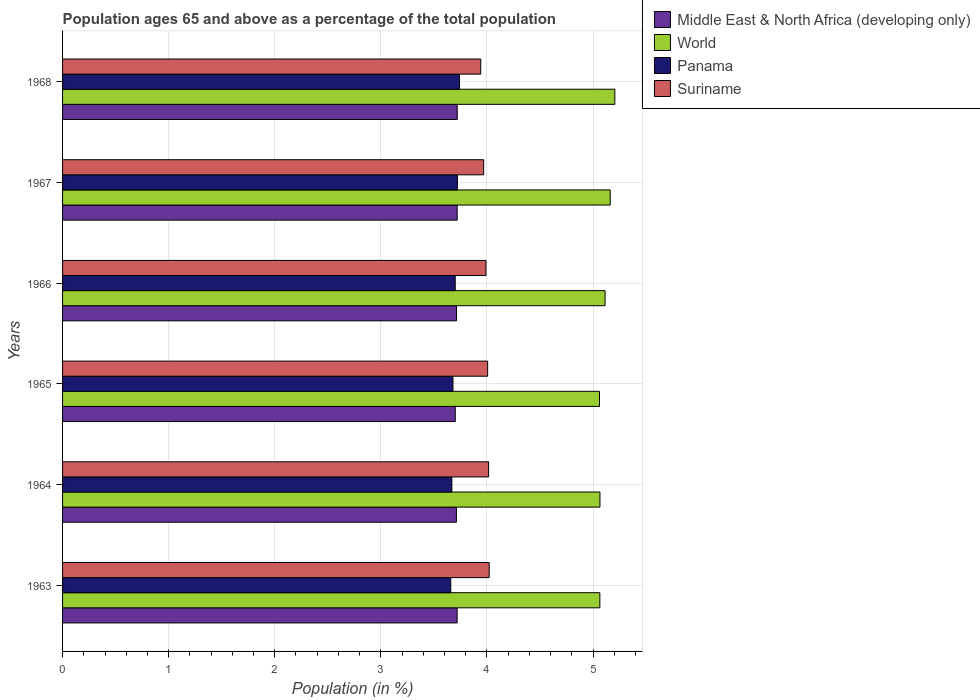How many bars are there on the 4th tick from the bottom?
Give a very brief answer. 4. What is the label of the 1st group of bars from the top?
Offer a very short reply. 1968. What is the percentage of the population ages 65 and above in Middle East & North Africa (developing only) in 1963?
Your response must be concise. 3.72. Across all years, what is the maximum percentage of the population ages 65 and above in Suriname?
Ensure brevity in your answer.  4.02. Across all years, what is the minimum percentage of the population ages 65 and above in Middle East & North Africa (developing only)?
Give a very brief answer. 3.7. In which year was the percentage of the population ages 65 and above in Panama maximum?
Keep it short and to the point. 1968. In which year was the percentage of the population ages 65 and above in Middle East & North Africa (developing only) minimum?
Offer a terse response. 1965. What is the total percentage of the population ages 65 and above in Middle East & North Africa (developing only) in the graph?
Keep it short and to the point. 22.28. What is the difference between the percentage of the population ages 65 and above in Suriname in 1966 and that in 1968?
Provide a short and direct response. 0.05. What is the difference between the percentage of the population ages 65 and above in World in 1966 and the percentage of the population ages 65 and above in Panama in 1967?
Your response must be concise. 1.39. What is the average percentage of the population ages 65 and above in Panama per year?
Offer a very short reply. 3.7. In the year 1967, what is the difference between the percentage of the population ages 65 and above in Suriname and percentage of the population ages 65 and above in Panama?
Your answer should be very brief. 0.25. What is the ratio of the percentage of the population ages 65 and above in Middle East & North Africa (developing only) in 1963 to that in 1964?
Keep it short and to the point. 1. Is the difference between the percentage of the population ages 65 and above in Suriname in 1964 and 1966 greater than the difference between the percentage of the population ages 65 and above in Panama in 1964 and 1966?
Ensure brevity in your answer.  Yes. What is the difference between the highest and the second highest percentage of the population ages 65 and above in Middle East & North Africa (developing only)?
Offer a terse response. 0. What is the difference between the highest and the lowest percentage of the population ages 65 and above in World?
Keep it short and to the point. 0.14. In how many years, is the percentage of the population ages 65 and above in World greater than the average percentage of the population ages 65 and above in World taken over all years?
Offer a very short reply. 3. Is the sum of the percentage of the population ages 65 and above in Panama in 1966 and 1967 greater than the maximum percentage of the population ages 65 and above in Suriname across all years?
Offer a terse response. Yes. Is it the case that in every year, the sum of the percentage of the population ages 65 and above in Middle East & North Africa (developing only) and percentage of the population ages 65 and above in World is greater than the sum of percentage of the population ages 65 and above in Panama and percentage of the population ages 65 and above in Suriname?
Keep it short and to the point. Yes. What does the 3rd bar from the bottom in 1964 represents?
Provide a short and direct response. Panama. How many years are there in the graph?
Keep it short and to the point. 6. Are the values on the major ticks of X-axis written in scientific E-notation?
Your answer should be compact. No. Where does the legend appear in the graph?
Offer a terse response. Top right. What is the title of the graph?
Your response must be concise. Population ages 65 and above as a percentage of the total population. Does "Caribbean small states" appear as one of the legend labels in the graph?
Your answer should be compact. No. What is the label or title of the Y-axis?
Offer a terse response. Years. What is the Population (in %) of Middle East & North Africa (developing only) in 1963?
Ensure brevity in your answer.  3.72. What is the Population (in %) in World in 1963?
Offer a very short reply. 5.06. What is the Population (in %) of Panama in 1963?
Make the answer very short. 3.66. What is the Population (in %) of Suriname in 1963?
Make the answer very short. 4.02. What is the Population (in %) of Middle East & North Africa (developing only) in 1964?
Offer a very short reply. 3.71. What is the Population (in %) in World in 1964?
Provide a short and direct response. 5.07. What is the Population (in %) of Panama in 1964?
Offer a terse response. 3.67. What is the Population (in %) of Suriname in 1964?
Make the answer very short. 4.02. What is the Population (in %) of Middle East & North Africa (developing only) in 1965?
Provide a short and direct response. 3.7. What is the Population (in %) in World in 1965?
Provide a succinct answer. 5.06. What is the Population (in %) of Panama in 1965?
Ensure brevity in your answer.  3.68. What is the Population (in %) in Suriname in 1965?
Offer a terse response. 4.01. What is the Population (in %) in Middle East & North Africa (developing only) in 1966?
Provide a succinct answer. 3.71. What is the Population (in %) in World in 1966?
Provide a short and direct response. 5.11. What is the Population (in %) in Panama in 1966?
Your answer should be compact. 3.7. What is the Population (in %) in Suriname in 1966?
Your answer should be compact. 3.99. What is the Population (in %) in Middle East & North Africa (developing only) in 1967?
Your response must be concise. 3.72. What is the Population (in %) of World in 1967?
Give a very brief answer. 5.16. What is the Population (in %) of Panama in 1967?
Give a very brief answer. 3.72. What is the Population (in %) of Suriname in 1967?
Your answer should be compact. 3.97. What is the Population (in %) in Middle East & North Africa (developing only) in 1968?
Provide a short and direct response. 3.72. What is the Population (in %) in World in 1968?
Your answer should be compact. 5.21. What is the Population (in %) of Panama in 1968?
Provide a succinct answer. 3.74. What is the Population (in %) in Suriname in 1968?
Your answer should be very brief. 3.94. Across all years, what is the maximum Population (in %) in Middle East & North Africa (developing only)?
Provide a short and direct response. 3.72. Across all years, what is the maximum Population (in %) of World?
Your answer should be compact. 5.21. Across all years, what is the maximum Population (in %) in Panama?
Your response must be concise. 3.74. Across all years, what is the maximum Population (in %) in Suriname?
Offer a terse response. 4.02. Across all years, what is the minimum Population (in %) in Middle East & North Africa (developing only)?
Your response must be concise. 3.7. Across all years, what is the minimum Population (in %) in World?
Provide a succinct answer. 5.06. Across all years, what is the minimum Population (in %) of Panama?
Make the answer very short. 3.66. Across all years, what is the minimum Population (in %) of Suriname?
Ensure brevity in your answer.  3.94. What is the total Population (in %) in Middle East & North Africa (developing only) in the graph?
Your answer should be very brief. 22.28. What is the total Population (in %) of World in the graph?
Provide a succinct answer. 30.67. What is the total Population (in %) in Panama in the graph?
Your answer should be very brief. 22.17. What is the total Population (in %) of Suriname in the graph?
Provide a short and direct response. 23.94. What is the difference between the Population (in %) in Middle East & North Africa (developing only) in 1963 and that in 1964?
Give a very brief answer. 0.01. What is the difference between the Population (in %) of World in 1963 and that in 1964?
Keep it short and to the point. -0. What is the difference between the Population (in %) in Panama in 1963 and that in 1964?
Ensure brevity in your answer.  -0.01. What is the difference between the Population (in %) of Suriname in 1963 and that in 1964?
Offer a terse response. 0.01. What is the difference between the Population (in %) in Middle East & North Africa (developing only) in 1963 and that in 1965?
Your answer should be very brief. 0.02. What is the difference between the Population (in %) of World in 1963 and that in 1965?
Provide a succinct answer. 0. What is the difference between the Population (in %) in Panama in 1963 and that in 1965?
Your answer should be very brief. -0.02. What is the difference between the Population (in %) in Suriname in 1963 and that in 1965?
Provide a short and direct response. 0.01. What is the difference between the Population (in %) of Middle East & North Africa (developing only) in 1963 and that in 1966?
Make the answer very short. 0.01. What is the difference between the Population (in %) of World in 1963 and that in 1966?
Your response must be concise. -0.05. What is the difference between the Population (in %) of Panama in 1963 and that in 1966?
Ensure brevity in your answer.  -0.04. What is the difference between the Population (in %) in Suriname in 1963 and that in 1966?
Make the answer very short. 0.03. What is the difference between the Population (in %) of Middle East & North Africa (developing only) in 1963 and that in 1967?
Offer a terse response. -0. What is the difference between the Population (in %) in World in 1963 and that in 1967?
Your response must be concise. -0.1. What is the difference between the Population (in %) of Panama in 1963 and that in 1967?
Offer a very short reply. -0.06. What is the difference between the Population (in %) of Suriname in 1963 and that in 1967?
Your answer should be compact. 0.05. What is the difference between the Population (in %) of Middle East & North Africa (developing only) in 1963 and that in 1968?
Keep it short and to the point. -0. What is the difference between the Population (in %) in World in 1963 and that in 1968?
Your answer should be very brief. -0.14. What is the difference between the Population (in %) of Panama in 1963 and that in 1968?
Give a very brief answer. -0.08. What is the difference between the Population (in %) in Suriname in 1963 and that in 1968?
Provide a succinct answer. 0.08. What is the difference between the Population (in %) of Middle East & North Africa (developing only) in 1964 and that in 1965?
Your answer should be compact. 0.01. What is the difference between the Population (in %) in World in 1964 and that in 1965?
Offer a very short reply. 0. What is the difference between the Population (in %) of Panama in 1964 and that in 1965?
Provide a succinct answer. -0.01. What is the difference between the Population (in %) in Suriname in 1964 and that in 1965?
Ensure brevity in your answer.  0.01. What is the difference between the Population (in %) of Middle East & North Africa (developing only) in 1964 and that in 1966?
Give a very brief answer. -0. What is the difference between the Population (in %) in World in 1964 and that in 1966?
Provide a short and direct response. -0.05. What is the difference between the Population (in %) of Panama in 1964 and that in 1966?
Provide a short and direct response. -0.03. What is the difference between the Population (in %) of Suriname in 1964 and that in 1966?
Your response must be concise. 0.02. What is the difference between the Population (in %) of Middle East & North Africa (developing only) in 1964 and that in 1967?
Your answer should be compact. -0.01. What is the difference between the Population (in %) in World in 1964 and that in 1967?
Offer a terse response. -0.1. What is the difference between the Population (in %) in Panama in 1964 and that in 1967?
Ensure brevity in your answer.  -0.05. What is the difference between the Population (in %) in Suriname in 1964 and that in 1967?
Your answer should be compact. 0.05. What is the difference between the Population (in %) in Middle East & North Africa (developing only) in 1964 and that in 1968?
Offer a very short reply. -0.01. What is the difference between the Population (in %) in World in 1964 and that in 1968?
Your answer should be very brief. -0.14. What is the difference between the Population (in %) in Panama in 1964 and that in 1968?
Provide a short and direct response. -0.07. What is the difference between the Population (in %) of Suriname in 1964 and that in 1968?
Make the answer very short. 0.07. What is the difference between the Population (in %) of Middle East & North Africa (developing only) in 1965 and that in 1966?
Provide a short and direct response. -0.01. What is the difference between the Population (in %) of World in 1965 and that in 1966?
Provide a succinct answer. -0.05. What is the difference between the Population (in %) of Panama in 1965 and that in 1966?
Your answer should be very brief. -0.02. What is the difference between the Population (in %) of Suriname in 1965 and that in 1966?
Make the answer very short. 0.02. What is the difference between the Population (in %) in Middle East & North Africa (developing only) in 1965 and that in 1967?
Offer a very short reply. -0.02. What is the difference between the Population (in %) in World in 1965 and that in 1967?
Provide a short and direct response. -0.1. What is the difference between the Population (in %) in Panama in 1965 and that in 1967?
Give a very brief answer. -0.04. What is the difference between the Population (in %) in Suriname in 1965 and that in 1967?
Offer a very short reply. 0.04. What is the difference between the Population (in %) in Middle East & North Africa (developing only) in 1965 and that in 1968?
Give a very brief answer. -0.02. What is the difference between the Population (in %) of World in 1965 and that in 1968?
Ensure brevity in your answer.  -0.14. What is the difference between the Population (in %) in Panama in 1965 and that in 1968?
Provide a succinct answer. -0.06. What is the difference between the Population (in %) of Suriname in 1965 and that in 1968?
Provide a short and direct response. 0.07. What is the difference between the Population (in %) of Middle East & North Africa (developing only) in 1966 and that in 1967?
Provide a short and direct response. -0.01. What is the difference between the Population (in %) in World in 1966 and that in 1967?
Your answer should be very brief. -0.05. What is the difference between the Population (in %) of Panama in 1966 and that in 1967?
Your response must be concise. -0.02. What is the difference between the Population (in %) in Suriname in 1966 and that in 1967?
Provide a succinct answer. 0.02. What is the difference between the Population (in %) in Middle East & North Africa (developing only) in 1966 and that in 1968?
Your answer should be very brief. -0.01. What is the difference between the Population (in %) in World in 1966 and that in 1968?
Offer a terse response. -0.09. What is the difference between the Population (in %) of Panama in 1966 and that in 1968?
Your answer should be compact. -0.04. What is the difference between the Population (in %) of Suriname in 1966 and that in 1968?
Give a very brief answer. 0.05. What is the difference between the Population (in %) in Middle East & North Africa (developing only) in 1967 and that in 1968?
Your response must be concise. -0. What is the difference between the Population (in %) in World in 1967 and that in 1968?
Your answer should be very brief. -0.04. What is the difference between the Population (in %) in Panama in 1967 and that in 1968?
Your answer should be compact. -0.02. What is the difference between the Population (in %) of Suriname in 1967 and that in 1968?
Make the answer very short. 0.03. What is the difference between the Population (in %) in Middle East & North Africa (developing only) in 1963 and the Population (in %) in World in 1964?
Ensure brevity in your answer.  -1.35. What is the difference between the Population (in %) in Middle East & North Africa (developing only) in 1963 and the Population (in %) in Panama in 1964?
Provide a succinct answer. 0.05. What is the difference between the Population (in %) in Middle East & North Africa (developing only) in 1963 and the Population (in %) in Suriname in 1964?
Keep it short and to the point. -0.3. What is the difference between the Population (in %) in World in 1963 and the Population (in %) in Panama in 1964?
Offer a terse response. 1.39. What is the difference between the Population (in %) in World in 1963 and the Population (in %) in Suriname in 1964?
Ensure brevity in your answer.  1.05. What is the difference between the Population (in %) in Panama in 1963 and the Population (in %) in Suriname in 1964?
Ensure brevity in your answer.  -0.36. What is the difference between the Population (in %) of Middle East & North Africa (developing only) in 1963 and the Population (in %) of World in 1965?
Offer a terse response. -1.34. What is the difference between the Population (in %) in Middle East & North Africa (developing only) in 1963 and the Population (in %) in Panama in 1965?
Keep it short and to the point. 0.04. What is the difference between the Population (in %) of Middle East & North Africa (developing only) in 1963 and the Population (in %) of Suriname in 1965?
Offer a terse response. -0.29. What is the difference between the Population (in %) of World in 1963 and the Population (in %) of Panama in 1965?
Your response must be concise. 1.38. What is the difference between the Population (in %) of World in 1963 and the Population (in %) of Suriname in 1965?
Offer a very short reply. 1.06. What is the difference between the Population (in %) of Panama in 1963 and the Population (in %) of Suriname in 1965?
Provide a succinct answer. -0.35. What is the difference between the Population (in %) in Middle East & North Africa (developing only) in 1963 and the Population (in %) in World in 1966?
Give a very brief answer. -1.39. What is the difference between the Population (in %) in Middle East & North Africa (developing only) in 1963 and the Population (in %) in Panama in 1966?
Offer a terse response. 0.02. What is the difference between the Population (in %) in Middle East & North Africa (developing only) in 1963 and the Population (in %) in Suriname in 1966?
Make the answer very short. -0.27. What is the difference between the Population (in %) in World in 1963 and the Population (in %) in Panama in 1966?
Make the answer very short. 1.36. What is the difference between the Population (in %) of World in 1963 and the Population (in %) of Suriname in 1966?
Your answer should be very brief. 1.07. What is the difference between the Population (in %) of Panama in 1963 and the Population (in %) of Suriname in 1966?
Keep it short and to the point. -0.33. What is the difference between the Population (in %) in Middle East & North Africa (developing only) in 1963 and the Population (in %) in World in 1967?
Keep it short and to the point. -1.44. What is the difference between the Population (in %) in Middle East & North Africa (developing only) in 1963 and the Population (in %) in Panama in 1967?
Provide a short and direct response. -0. What is the difference between the Population (in %) of Middle East & North Africa (developing only) in 1963 and the Population (in %) of Suriname in 1967?
Make the answer very short. -0.25. What is the difference between the Population (in %) in World in 1963 and the Population (in %) in Panama in 1967?
Offer a terse response. 1.34. What is the difference between the Population (in %) of World in 1963 and the Population (in %) of Suriname in 1967?
Keep it short and to the point. 1.1. What is the difference between the Population (in %) in Panama in 1963 and the Population (in %) in Suriname in 1967?
Provide a short and direct response. -0.31. What is the difference between the Population (in %) in Middle East & North Africa (developing only) in 1963 and the Population (in %) in World in 1968?
Give a very brief answer. -1.49. What is the difference between the Population (in %) in Middle East & North Africa (developing only) in 1963 and the Population (in %) in Panama in 1968?
Ensure brevity in your answer.  -0.02. What is the difference between the Population (in %) in Middle East & North Africa (developing only) in 1963 and the Population (in %) in Suriname in 1968?
Offer a terse response. -0.22. What is the difference between the Population (in %) of World in 1963 and the Population (in %) of Panama in 1968?
Provide a succinct answer. 1.32. What is the difference between the Population (in %) of World in 1963 and the Population (in %) of Suriname in 1968?
Offer a very short reply. 1.12. What is the difference between the Population (in %) in Panama in 1963 and the Population (in %) in Suriname in 1968?
Your answer should be compact. -0.28. What is the difference between the Population (in %) of Middle East & North Africa (developing only) in 1964 and the Population (in %) of World in 1965?
Make the answer very short. -1.35. What is the difference between the Population (in %) in Middle East & North Africa (developing only) in 1964 and the Population (in %) in Panama in 1965?
Offer a very short reply. 0.03. What is the difference between the Population (in %) in Middle East & North Africa (developing only) in 1964 and the Population (in %) in Suriname in 1965?
Make the answer very short. -0.29. What is the difference between the Population (in %) in World in 1964 and the Population (in %) in Panama in 1965?
Ensure brevity in your answer.  1.39. What is the difference between the Population (in %) of World in 1964 and the Population (in %) of Suriname in 1965?
Your answer should be compact. 1.06. What is the difference between the Population (in %) of Panama in 1964 and the Population (in %) of Suriname in 1965?
Keep it short and to the point. -0.34. What is the difference between the Population (in %) in Middle East & North Africa (developing only) in 1964 and the Population (in %) in World in 1966?
Provide a succinct answer. -1.4. What is the difference between the Population (in %) in Middle East & North Africa (developing only) in 1964 and the Population (in %) in Panama in 1966?
Make the answer very short. 0.01. What is the difference between the Population (in %) of Middle East & North Africa (developing only) in 1964 and the Population (in %) of Suriname in 1966?
Keep it short and to the point. -0.28. What is the difference between the Population (in %) in World in 1964 and the Population (in %) in Panama in 1966?
Make the answer very short. 1.36. What is the difference between the Population (in %) in World in 1964 and the Population (in %) in Suriname in 1966?
Provide a succinct answer. 1.07. What is the difference between the Population (in %) in Panama in 1964 and the Population (in %) in Suriname in 1966?
Your answer should be compact. -0.32. What is the difference between the Population (in %) of Middle East & North Africa (developing only) in 1964 and the Population (in %) of World in 1967?
Your answer should be very brief. -1.45. What is the difference between the Population (in %) in Middle East & North Africa (developing only) in 1964 and the Population (in %) in Panama in 1967?
Your response must be concise. -0.01. What is the difference between the Population (in %) of Middle East & North Africa (developing only) in 1964 and the Population (in %) of Suriname in 1967?
Offer a terse response. -0.26. What is the difference between the Population (in %) of World in 1964 and the Population (in %) of Panama in 1967?
Make the answer very short. 1.34. What is the difference between the Population (in %) of World in 1964 and the Population (in %) of Suriname in 1967?
Make the answer very short. 1.1. What is the difference between the Population (in %) in Panama in 1964 and the Population (in %) in Suriname in 1967?
Keep it short and to the point. -0.3. What is the difference between the Population (in %) of Middle East & North Africa (developing only) in 1964 and the Population (in %) of World in 1968?
Offer a very short reply. -1.49. What is the difference between the Population (in %) of Middle East & North Africa (developing only) in 1964 and the Population (in %) of Panama in 1968?
Give a very brief answer. -0.03. What is the difference between the Population (in %) in Middle East & North Africa (developing only) in 1964 and the Population (in %) in Suriname in 1968?
Make the answer very short. -0.23. What is the difference between the Population (in %) of World in 1964 and the Population (in %) of Panama in 1968?
Your answer should be compact. 1.32. What is the difference between the Population (in %) in World in 1964 and the Population (in %) in Suriname in 1968?
Your answer should be compact. 1.12. What is the difference between the Population (in %) of Panama in 1964 and the Population (in %) of Suriname in 1968?
Ensure brevity in your answer.  -0.27. What is the difference between the Population (in %) of Middle East & North Africa (developing only) in 1965 and the Population (in %) of World in 1966?
Provide a short and direct response. -1.41. What is the difference between the Population (in %) of Middle East & North Africa (developing only) in 1965 and the Population (in %) of Panama in 1966?
Your answer should be compact. 0. What is the difference between the Population (in %) of Middle East & North Africa (developing only) in 1965 and the Population (in %) of Suriname in 1966?
Provide a succinct answer. -0.29. What is the difference between the Population (in %) in World in 1965 and the Population (in %) in Panama in 1966?
Offer a terse response. 1.36. What is the difference between the Population (in %) of World in 1965 and the Population (in %) of Suriname in 1966?
Your answer should be compact. 1.07. What is the difference between the Population (in %) of Panama in 1965 and the Population (in %) of Suriname in 1966?
Your answer should be very brief. -0.31. What is the difference between the Population (in %) in Middle East & North Africa (developing only) in 1965 and the Population (in %) in World in 1967?
Make the answer very short. -1.46. What is the difference between the Population (in %) of Middle East & North Africa (developing only) in 1965 and the Population (in %) of Panama in 1967?
Provide a short and direct response. -0.02. What is the difference between the Population (in %) of Middle East & North Africa (developing only) in 1965 and the Population (in %) of Suriname in 1967?
Ensure brevity in your answer.  -0.27. What is the difference between the Population (in %) of World in 1965 and the Population (in %) of Panama in 1967?
Give a very brief answer. 1.34. What is the difference between the Population (in %) of World in 1965 and the Population (in %) of Suriname in 1967?
Your response must be concise. 1.09. What is the difference between the Population (in %) of Panama in 1965 and the Population (in %) of Suriname in 1967?
Offer a very short reply. -0.29. What is the difference between the Population (in %) in Middle East & North Africa (developing only) in 1965 and the Population (in %) in World in 1968?
Your answer should be very brief. -1.5. What is the difference between the Population (in %) of Middle East & North Africa (developing only) in 1965 and the Population (in %) of Panama in 1968?
Provide a succinct answer. -0.04. What is the difference between the Population (in %) in Middle East & North Africa (developing only) in 1965 and the Population (in %) in Suriname in 1968?
Provide a succinct answer. -0.24. What is the difference between the Population (in %) in World in 1965 and the Population (in %) in Panama in 1968?
Give a very brief answer. 1.32. What is the difference between the Population (in %) of World in 1965 and the Population (in %) of Suriname in 1968?
Ensure brevity in your answer.  1.12. What is the difference between the Population (in %) of Panama in 1965 and the Population (in %) of Suriname in 1968?
Provide a succinct answer. -0.26. What is the difference between the Population (in %) of Middle East & North Africa (developing only) in 1966 and the Population (in %) of World in 1967?
Your answer should be compact. -1.45. What is the difference between the Population (in %) in Middle East & North Africa (developing only) in 1966 and the Population (in %) in Panama in 1967?
Your answer should be compact. -0.01. What is the difference between the Population (in %) in Middle East & North Africa (developing only) in 1966 and the Population (in %) in Suriname in 1967?
Your response must be concise. -0.26. What is the difference between the Population (in %) of World in 1966 and the Population (in %) of Panama in 1967?
Your answer should be compact. 1.39. What is the difference between the Population (in %) in World in 1966 and the Population (in %) in Suriname in 1967?
Make the answer very short. 1.14. What is the difference between the Population (in %) of Panama in 1966 and the Population (in %) of Suriname in 1967?
Make the answer very short. -0.27. What is the difference between the Population (in %) in Middle East & North Africa (developing only) in 1966 and the Population (in %) in World in 1968?
Make the answer very short. -1.49. What is the difference between the Population (in %) of Middle East & North Africa (developing only) in 1966 and the Population (in %) of Panama in 1968?
Your answer should be compact. -0.03. What is the difference between the Population (in %) of Middle East & North Africa (developing only) in 1966 and the Population (in %) of Suriname in 1968?
Provide a short and direct response. -0.23. What is the difference between the Population (in %) of World in 1966 and the Population (in %) of Panama in 1968?
Your answer should be compact. 1.37. What is the difference between the Population (in %) in World in 1966 and the Population (in %) in Suriname in 1968?
Offer a very short reply. 1.17. What is the difference between the Population (in %) in Panama in 1966 and the Population (in %) in Suriname in 1968?
Your response must be concise. -0.24. What is the difference between the Population (in %) in Middle East & North Africa (developing only) in 1967 and the Population (in %) in World in 1968?
Keep it short and to the point. -1.49. What is the difference between the Population (in %) in Middle East & North Africa (developing only) in 1967 and the Population (in %) in Panama in 1968?
Provide a succinct answer. -0.02. What is the difference between the Population (in %) in Middle East & North Africa (developing only) in 1967 and the Population (in %) in Suriname in 1968?
Keep it short and to the point. -0.22. What is the difference between the Population (in %) in World in 1967 and the Population (in %) in Panama in 1968?
Your answer should be compact. 1.42. What is the difference between the Population (in %) of World in 1967 and the Population (in %) of Suriname in 1968?
Offer a terse response. 1.22. What is the difference between the Population (in %) of Panama in 1967 and the Population (in %) of Suriname in 1968?
Your response must be concise. -0.22. What is the average Population (in %) of Middle East & North Africa (developing only) per year?
Provide a short and direct response. 3.71. What is the average Population (in %) in World per year?
Provide a short and direct response. 5.11. What is the average Population (in %) of Panama per year?
Give a very brief answer. 3.7. What is the average Population (in %) in Suriname per year?
Make the answer very short. 3.99. In the year 1963, what is the difference between the Population (in %) in Middle East & North Africa (developing only) and Population (in %) in World?
Keep it short and to the point. -1.35. In the year 1963, what is the difference between the Population (in %) in Middle East & North Africa (developing only) and Population (in %) in Panama?
Your answer should be compact. 0.06. In the year 1963, what is the difference between the Population (in %) in Middle East & North Africa (developing only) and Population (in %) in Suriname?
Your answer should be compact. -0.3. In the year 1963, what is the difference between the Population (in %) in World and Population (in %) in Panama?
Your answer should be compact. 1.41. In the year 1963, what is the difference between the Population (in %) of World and Population (in %) of Suriname?
Provide a succinct answer. 1.04. In the year 1963, what is the difference between the Population (in %) in Panama and Population (in %) in Suriname?
Give a very brief answer. -0.36. In the year 1964, what is the difference between the Population (in %) of Middle East & North Africa (developing only) and Population (in %) of World?
Keep it short and to the point. -1.35. In the year 1964, what is the difference between the Population (in %) of Middle East & North Africa (developing only) and Population (in %) of Panama?
Give a very brief answer. 0.04. In the year 1964, what is the difference between the Population (in %) in Middle East & North Africa (developing only) and Population (in %) in Suriname?
Your answer should be very brief. -0.3. In the year 1964, what is the difference between the Population (in %) of World and Population (in %) of Panama?
Provide a succinct answer. 1.4. In the year 1964, what is the difference between the Population (in %) of World and Population (in %) of Suriname?
Make the answer very short. 1.05. In the year 1964, what is the difference between the Population (in %) in Panama and Population (in %) in Suriname?
Provide a short and direct response. -0.35. In the year 1965, what is the difference between the Population (in %) of Middle East & North Africa (developing only) and Population (in %) of World?
Your answer should be compact. -1.36. In the year 1965, what is the difference between the Population (in %) of Middle East & North Africa (developing only) and Population (in %) of Panama?
Offer a terse response. 0.02. In the year 1965, what is the difference between the Population (in %) of Middle East & North Africa (developing only) and Population (in %) of Suriname?
Give a very brief answer. -0.31. In the year 1965, what is the difference between the Population (in %) in World and Population (in %) in Panama?
Your response must be concise. 1.38. In the year 1965, what is the difference between the Population (in %) in World and Population (in %) in Suriname?
Make the answer very short. 1.05. In the year 1965, what is the difference between the Population (in %) in Panama and Population (in %) in Suriname?
Make the answer very short. -0.33. In the year 1966, what is the difference between the Population (in %) of Middle East & North Africa (developing only) and Population (in %) of World?
Keep it short and to the point. -1.4. In the year 1966, what is the difference between the Population (in %) in Middle East & North Africa (developing only) and Population (in %) in Panama?
Offer a terse response. 0.01. In the year 1966, what is the difference between the Population (in %) in Middle East & North Africa (developing only) and Population (in %) in Suriname?
Your answer should be very brief. -0.28. In the year 1966, what is the difference between the Population (in %) of World and Population (in %) of Panama?
Give a very brief answer. 1.41. In the year 1966, what is the difference between the Population (in %) of World and Population (in %) of Suriname?
Make the answer very short. 1.12. In the year 1966, what is the difference between the Population (in %) in Panama and Population (in %) in Suriname?
Give a very brief answer. -0.29. In the year 1967, what is the difference between the Population (in %) in Middle East & North Africa (developing only) and Population (in %) in World?
Your answer should be very brief. -1.44. In the year 1967, what is the difference between the Population (in %) of Middle East & North Africa (developing only) and Population (in %) of Panama?
Your answer should be compact. -0. In the year 1967, what is the difference between the Population (in %) in Middle East & North Africa (developing only) and Population (in %) in Suriname?
Your answer should be compact. -0.25. In the year 1967, what is the difference between the Population (in %) of World and Population (in %) of Panama?
Provide a short and direct response. 1.44. In the year 1967, what is the difference between the Population (in %) in World and Population (in %) in Suriname?
Give a very brief answer. 1.19. In the year 1967, what is the difference between the Population (in %) of Panama and Population (in %) of Suriname?
Offer a terse response. -0.25. In the year 1968, what is the difference between the Population (in %) of Middle East & North Africa (developing only) and Population (in %) of World?
Keep it short and to the point. -1.49. In the year 1968, what is the difference between the Population (in %) in Middle East & North Africa (developing only) and Population (in %) in Panama?
Provide a short and direct response. -0.02. In the year 1968, what is the difference between the Population (in %) of Middle East & North Africa (developing only) and Population (in %) of Suriname?
Provide a short and direct response. -0.22. In the year 1968, what is the difference between the Population (in %) of World and Population (in %) of Panama?
Provide a succinct answer. 1.46. In the year 1968, what is the difference between the Population (in %) in World and Population (in %) in Suriname?
Provide a succinct answer. 1.26. In the year 1968, what is the difference between the Population (in %) of Panama and Population (in %) of Suriname?
Offer a terse response. -0.2. What is the ratio of the Population (in %) of Middle East & North Africa (developing only) in 1963 to that in 1964?
Ensure brevity in your answer.  1. What is the ratio of the Population (in %) of World in 1963 to that in 1964?
Your response must be concise. 1. What is the ratio of the Population (in %) in Panama in 1963 to that in 1964?
Give a very brief answer. 1. What is the ratio of the Population (in %) in World in 1963 to that in 1965?
Offer a very short reply. 1. What is the ratio of the Population (in %) in Panama in 1963 to that in 1965?
Offer a terse response. 0.99. What is the ratio of the Population (in %) in Middle East & North Africa (developing only) in 1963 to that in 1966?
Provide a short and direct response. 1. What is the ratio of the Population (in %) in Panama in 1963 to that in 1966?
Offer a terse response. 0.99. What is the ratio of the Population (in %) in Suriname in 1963 to that in 1966?
Your response must be concise. 1.01. What is the ratio of the Population (in %) of World in 1963 to that in 1967?
Give a very brief answer. 0.98. What is the ratio of the Population (in %) of Panama in 1963 to that in 1967?
Your response must be concise. 0.98. What is the ratio of the Population (in %) of Suriname in 1963 to that in 1967?
Offer a very short reply. 1.01. What is the ratio of the Population (in %) of Middle East & North Africa (developing only) in 1963 to that in 1968?
Offer a terse response. 1. What is the ratio of the Population (in %) of World in 1963 to that in 1968?
Offer a very short reply. 0.97. What is the ratio of the Population (in %) in Panama in 1963 to that in 1968?
Provide a short and direct response. 0.98. What is the ratio of the Population (in %) in Suriname in 1963 to that in 1968?
Your response must be concise. 1.02. What is the ratio of the Population (in %) in Middle East & North Africa (developing only) in 1964 to that in 1965?
Your answer should be very brief. 1. What is the ratio of the Population (in %) in Middle East & North Africa (developing only) in 1964 to that in 1966?
Your response must be concise. 1. What is the ratio of the Population (in %) in World in 1964 to that in 1966?
Your answer should be compact. 0.99. What is the ratio of the Population (in %) in Suriname in 1964 to that in 1966?
Provide a succinct answer. 1.01. What is the ratio of the Population (in %) of World in 1964 to that in 1967?
Your answer should be compact. 0.98. What is the ratio of the Population (in %) of Panama in 1964 to that in 1967?
Ensure brevity in your answer.  0.99. What is the ratio of the Population (in %) in Suriname in 1964 to that in 1967?
Your answer should be very brief. 1.01. What is the ratio of the Population (in %) in Middle East & North Africa (developing only) in 1964 to that in 1968?
Your answer should be very brief. 1. What is the ratio of the Population (in %) in World in 1964 to that in 1968?
Your response must be concise. 0.97. What is the ratio of the Population (in %) of Panama in 1964 to that in 1968?
Your answer should be compact. 0.98. What is the ratio of the Population (in %) in Suriname in 1964 to that in 1968?
Provide a succinct answer. 1.02. What is the ratio of the Population (in %) of Panama in 1965 to that in 1966?
Make the answer very short. 0.99. What is the ratio of the Population (in %) of World in 1965 to that in 1967?
Keep it short and to the point. 0.98. What is the ratio of the Population (in %) in Panama in 1965 to that in 1967?
Your response must be concise. 0.99. What is the ratio of the Population (in %) in Suriname in 1965 to that in 1967?
Make the answer very short. 1.01. What is the ratio of the Population (in %) of Middle East & North Africa (developing only) in 1965 to that in 1968?
Offer a terse response. 0.99. What is the ratio of the Population (in %) in World in 1965 to that in 1968?
Your response must be concise. 0.97. What is the ratio of the Population (in %) in Panama in 1965 to that in 1968?
Ensure brevity in your answer.  0.98. What is the ratio of the Population (in %) of Suriname in 1965 to that in 1968?
Ensure brevity in your answer.  1.02. What is the ratio of the Population (in %) of Middle East & North Africa (developing only) in 1966 to that in 1967?
Your answer should be compact. 1. What is the ratio of the Population (in %) in World in 1966 to that in 1967?
Provide a short and direct response. 0.99. What is the ratio of the Population (in %) of World in 1966 to that in 1968?
Make the answer very short. 0.98. What is the ratio of the Population (in %) in Suriname in 1966 to that in 1968?
Provide a short and direct response. 1.01. What is the ratio of the Population (in %) in Middle East & North Africa (developing only) in 1967 to that in 1968?
Provide a short and direct response. 1. What is the ratio of the Population (in %) in World in 1967 to that in 1968?
Offer a terse response. 0.99. What is the difference between the highest and the second highest Population (in %) in Middle East & North Africa (developing only)?
Your answer should be compact. 0. What is the difference between the highest and the second highest Population (in %) in World?
Give a very brief answer. 0.04. What is the difference between the highest and the second highest Population (in %) of Panama?
Provide a succinct answer. 0.02. What is the difference between the highest and the second highest Population (in %) in Suriname?
Offer a very short reply. 0.01. What is the difference between the highest and the lowest Population (in %) of Middle East & North Africa (developing only)?
Your answer should be compact. 0.02. What is the difference between the highest and the lowest Population (in %) in World?
Make the answer very short. 0.14. What is the difference between the highest and the lowest Population (in %) in Panama?
Your answer should be very brief. 0.08. What is the difference between the highest and the lowest Population (in %) of Suriname?
Make the answer very short. 0.08. 